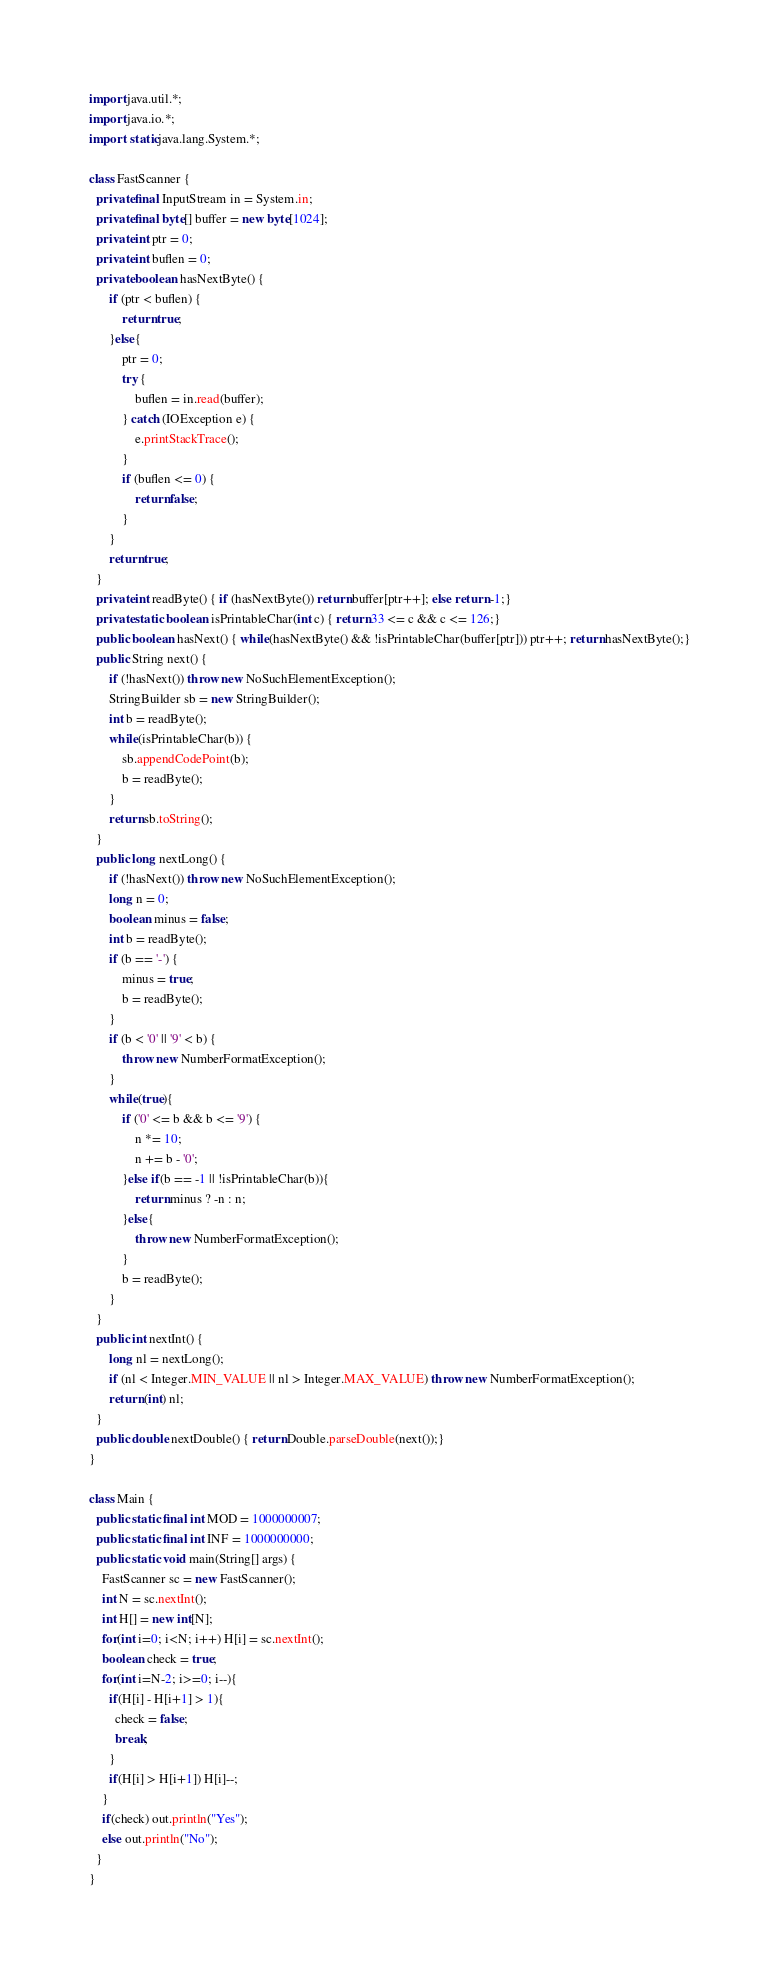<code> <loc_0><loc_0><loc_500><loc_500><_Java_>import java.util.*;
import java.io.*;
import static java.lang.System.*;

class FastScanner {
  private final InputStream in = System.in;
  private final byte[] buffer = new byte[1024];
  private int ptr = 0;
  private int buflen = 0;
  private boolean hasNextByte() {
      if (ptr < buflen) {
          return true;
      }else{
          ptr = 0;
          try {
              buflen = in.read(buffer);
          } catch (IOException e) {
              e.printStackTrace();
          }
          if (buflen <= 0) {
              return false;
          }
      }
      return true;
  }
  private int readByte() { if (hasNextByte()) return buffer[ptr++]; else return -1;}
  private static boolean isPrintableChar(int c) { return 33 <= c && c <= 126;}
  public boolean hasNext() { while(hasNextByte() && !isPrintableChar(buffer[ptr])) ptr++; return hasNextByte();}
  public String next() {
      if (!hasNext()) throw new NoSuchElementException();
      StringBuilder sb = new StringBuilder();
      int b = readByte();
      while(isPrintableChar(b)) {
          sb.appendCodePoint(b);
          b = readByte();
      }
      return sb.toString();
  }
  public long nextLong() {
      if (!hasNext()) throw new NoSuchElementException();
      long n = 0;
      boolean minus = false;
      int b = readByte();
      if (b == '-') {
          minus = true;
          b = readByte();
      }
      if (b < '0' || '9' < b) {
          throw new NumberFormatException();
      }
      while(true){
          if ('0' <= b && b <= '9') {
              n *= 10;
              n += b - '0';
          }else if(b == -1 || !isPrintableChar(b)){
              return minus ? -n : n;
          }else{
              throw new NumberFormatException();
          }
          b = readByte();
      }
  }
  public int nextInt() {
      long nl = nextLong();
      if (nl < Integer.MIN_VALUE || nl > Integer.MAX_VALUE) throw new NumberFormatException();
      return (int) nl;
  }
  public double nextDouble() { return Double.parseDouble(next());}
}

class Main {
  public static final int MOD = 1000000007;
  public static final int INF = 1000000000;
  public static void main(String[] args) {
    FastScanner sc = new FastScanner();
    int N = sc.nextInt();
    int H[] = new int[N];
    for(int i=0; i<N; i++) H[i] = sc.nextInt();
    boolean check = true;
    for(int i=N-2; i>=0; i--){
      if(H[i] - H[i+1] > 1){
        check = false;
        break;
      }
      if(H[i] > H[i+1]) H[i]--;
    }
    if(check) out.println("Yes");
    else out.println("No");
  }
}</code> 